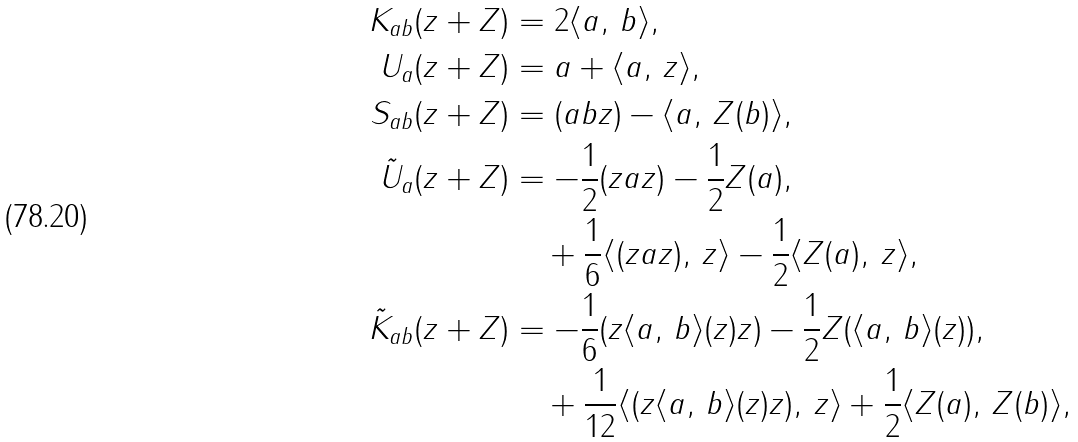<formula> <loc_0><loc_0><loc_500><loc_500>K _ { a b } ( z + Z ) & = 2 \langle a , \, b \rangle , \\ U _ { a } ( z + Z ) & = a + \langle a , \, z \rangle , \\ S _ { a b } ( z + Z ) & = ( a b z ) - \langle a , \, Z ( b ) \rangle , \\ \tilde { U } _ { a } ( z + Z ) & = - \frac { 1 } { 2 } ( z a z ) - \frac { 1 } { 2 } Z ( a ) , \\ & \quad + \frac { 1 } { 6 } \langle ( z a z ) , \, z \rangle - \frac { 1 } { 2 } \langle Z ( a ) , \, z \rangle , \\ \tilde { K } _ { a b } ( z + Z ) & = - \frac { 1 } { 6 } ( z \langle a , \, b \rangle ( z ) z ) - \frac { 1 } { 2 } Z ( \langle a , \, b \rangle ( z ) ) , \\ & \quad + \frac { 1 } { 1 2 } \langle ( z \langle a , \, b \rangle ( z ) z ) , \, z \rangle + \frac { 1 } { 2 } \langle Z ( a ) , \, Z ( b ) \rangle ,</formula> 